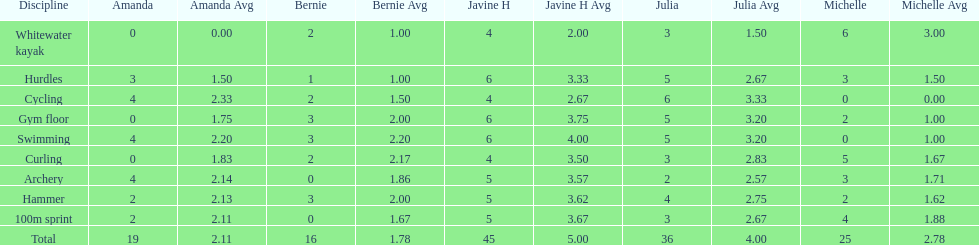Who earned the most total points? Javine H. 